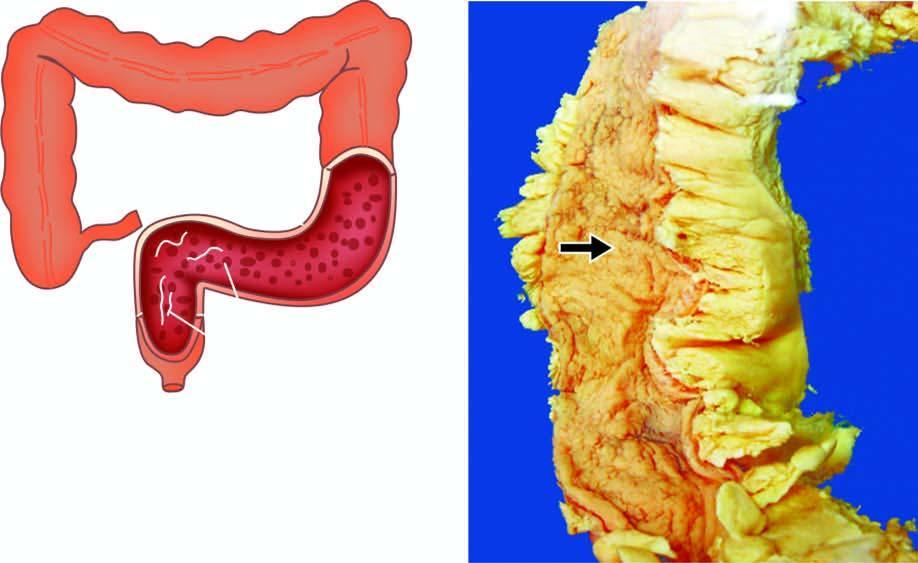re the congophilic areas narrow?
Answer the question using a single word or phrase. No 